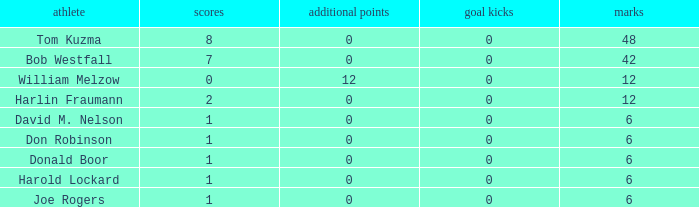Name the least touchdowns for joe rogers 1.0. 